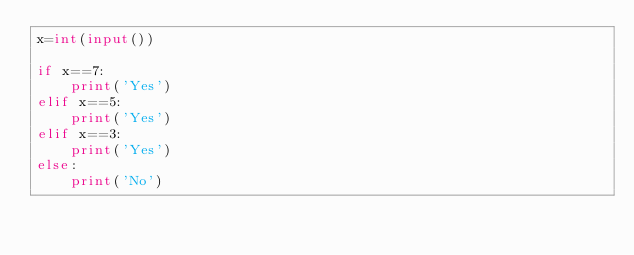<code> <loc_0><loc_0><loc_500><loc_500><_Python_>x=int(input())

if x==7:
  	print('Yes')
elif x==5:
  	print('Yes')
elif x==3:
  	print('Yes')
else:
  	print('No')</code> 